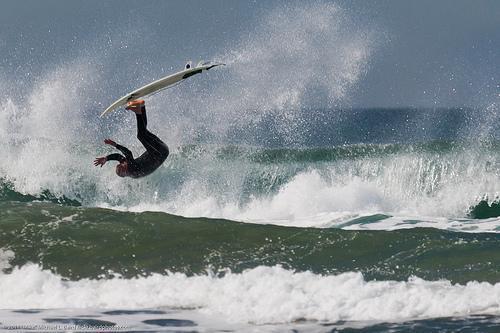How many men are there?
Give a very brief answer. 1. 